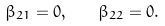Convert formula to latex. <formula><loc_0><loc_0><loc_500><loc_500>\beta _ { 2 1 } = 0 , \quad \beta _ { 2 2 } = 0 .</formula> 